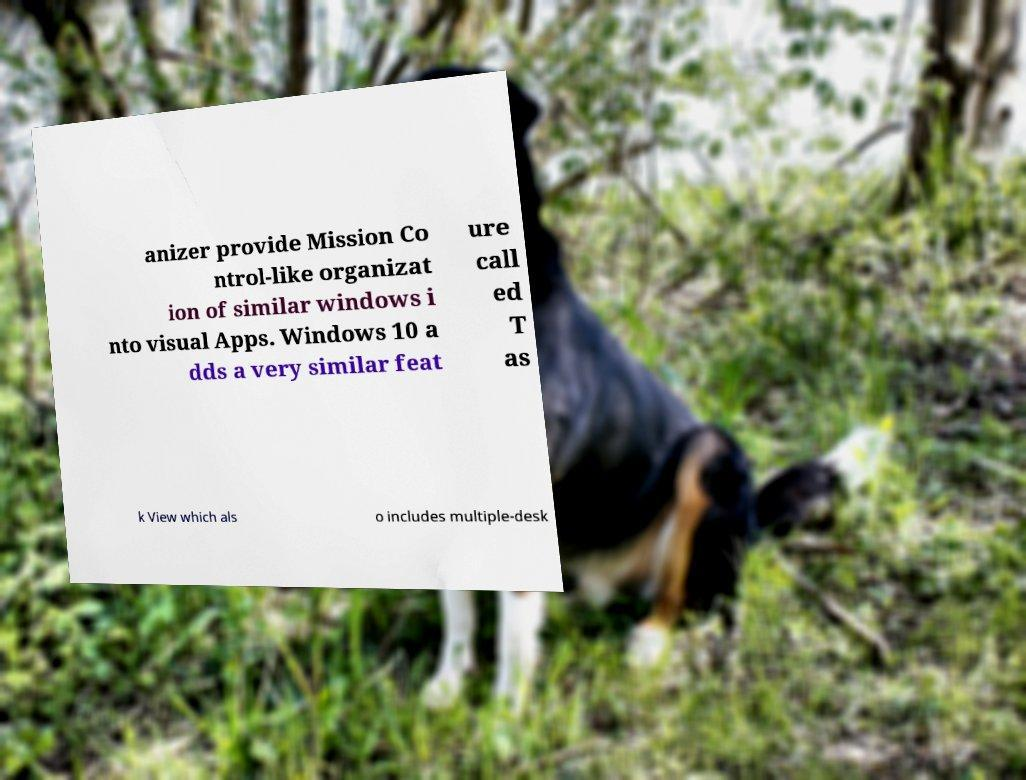I need the written content from this picture converted into text. Can you do that? anizer provide Mission Co ntrol-like organizat ion of similar windows i nto visual Apps. Windows 10 a dds a very similar feat ure call ed T as k View which als o includes multiple-desk 